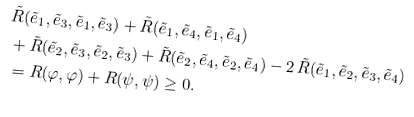<formula> <loc_0><loc_0><loc_500><loc_500>& \tilde { R } ( \tilde { e } _ { 1 } , \tilde { e } _ { 3 } , \tilde { e } _ { 1 } , \tilde { e } _ { 3 } ) + \tilde { R } ( \tilde { e } _ { 1 } , \tilde { e } _ { 4 } , \tilde { e } _ { 1 } , \tilde { e } _ { 4 } ) \\ & + \tilde { R } ( \tilde { e } _ { 2 } , \tilde { e } _ { 3 } , \tilde { e } _ { 2 } , \tilde { e } _ { 3 } ) + \tilde { R } ( \tilde { e } _ { 2 } , \tilde { e } _ { 4 } , \tilde { e } _ { 2 } , \tilde { e } _ { 4 } ) - 2 \, \tilde { R } ( \tilde { e } _ { 1 } , \tilde { e } _ { 2 } , \tilde { e } _ { 3 } , \tilde { e } _ { 4 } ) \\ & = R ( \varphi , \varphi ) + R ( \psi , \psi ) \geq 0 .</formula> 